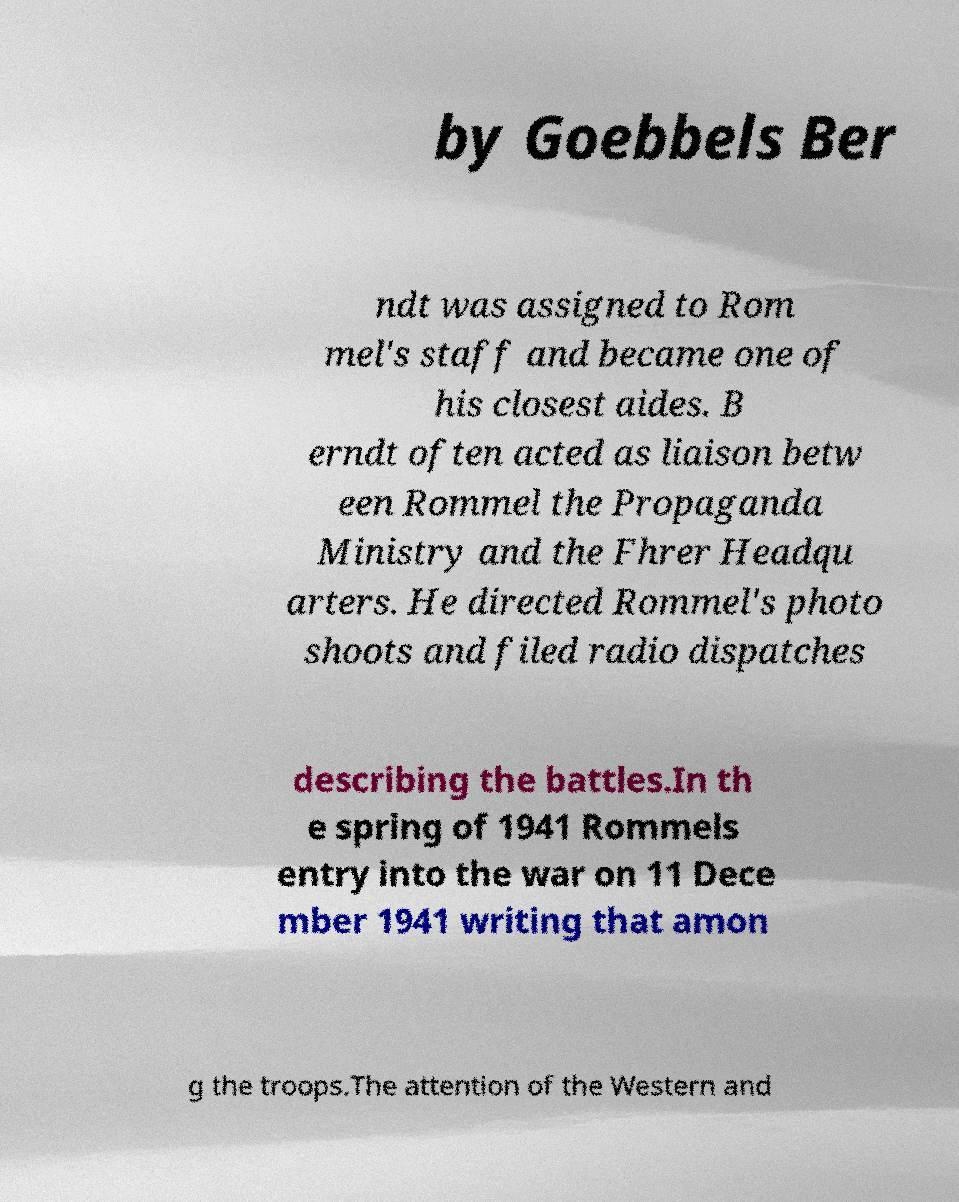What messages or text are displayed in this image? I need them in a readable, typed format. by Goebbels Ber ndt was assigned to Rom mel's staff and became one of his closest aides. B erndt often acted as liaison betw een Rommel the Propaganda Ministry and the Fhrer Headqu arters. He directed Rommel's photo shoots and filed radio dispatches describing the battles.In th e spring of 1941 Rommels entry into the war on 11 Dece mber 1941 writing that amon g the troops.The attention of the Western and 